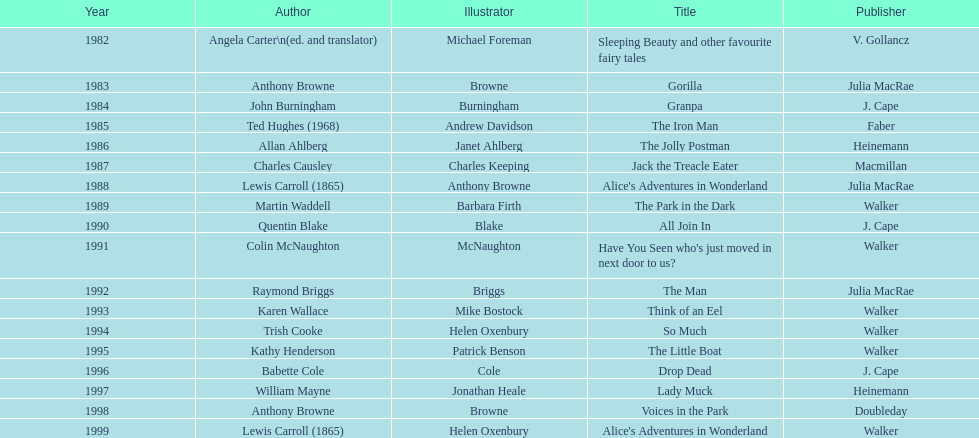What is the difference in years between the publication of angela carter's and anthony browne's titles? 1. 